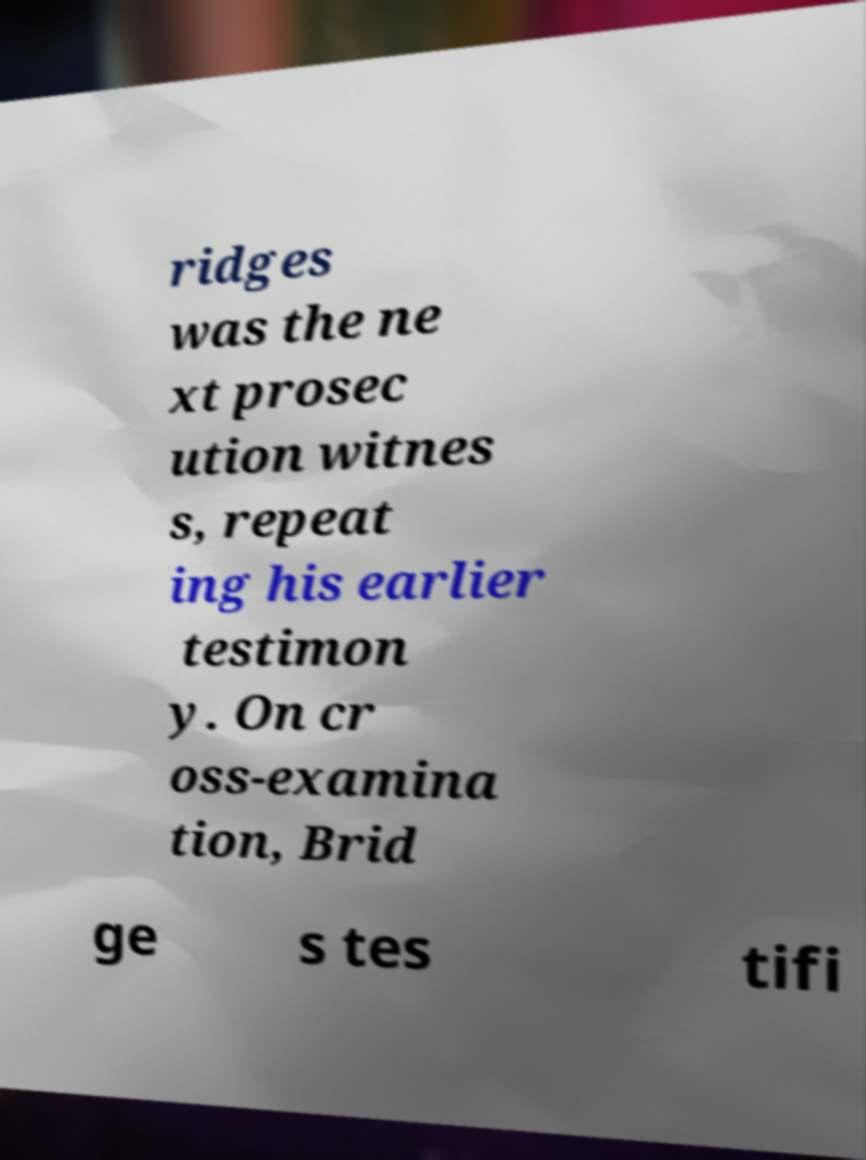Could you extract and type out the text from this image? ridges was the ne xt prosec ution witnes s, repeat ing his earlier testimon y. On cr oss-examina tion, Brid ge s tes tifi 